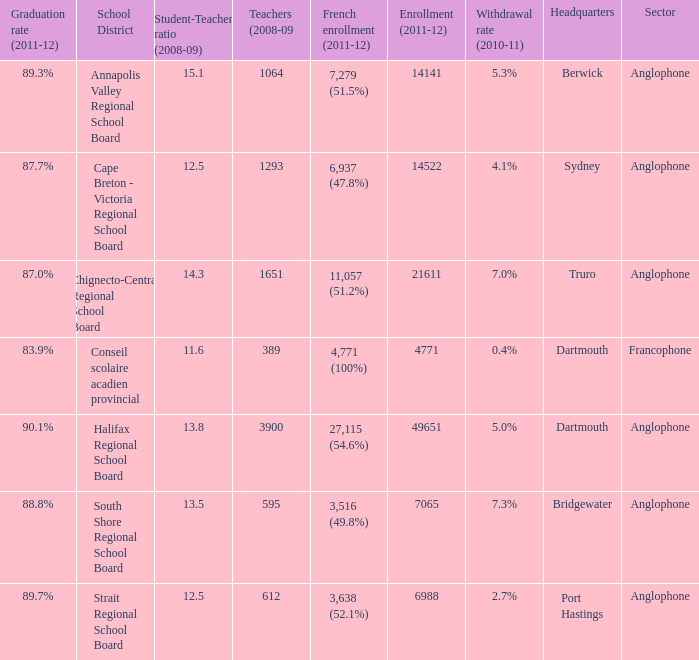Where is the headquarter located for the Annapolis Valley Regional School Board? Berwick. 